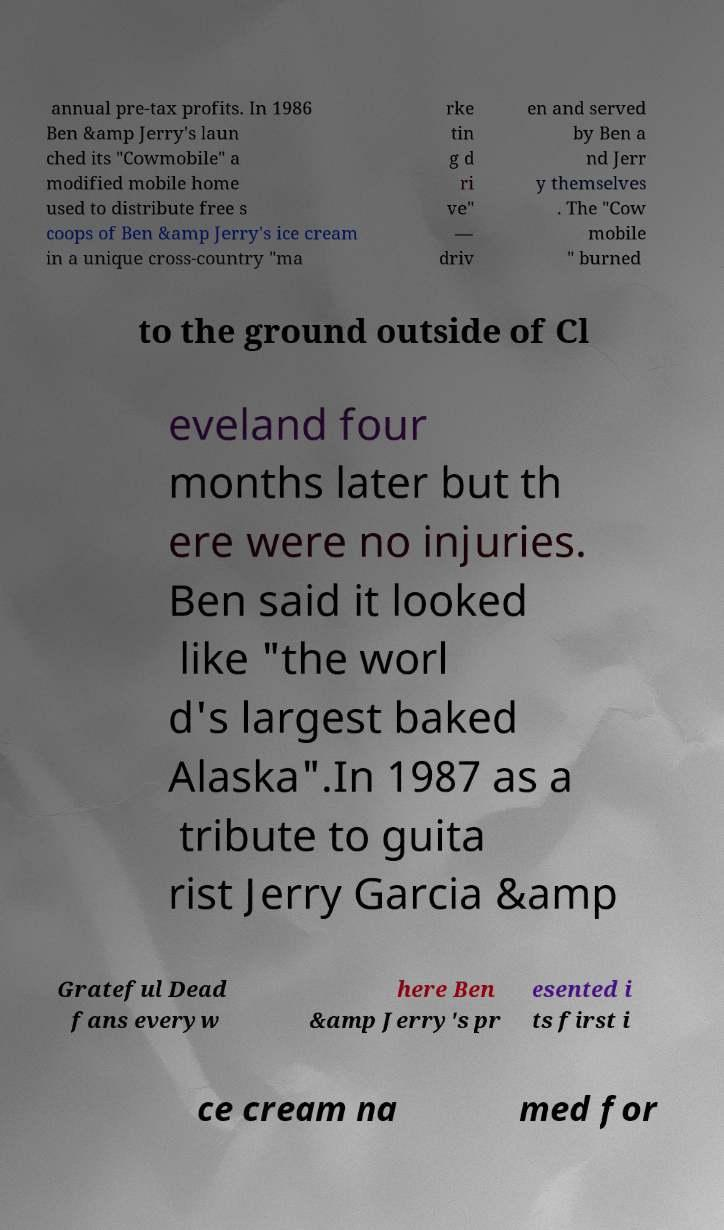I need the written content from this picture converted into text. Can you do that? annual pre-tax profits. In 1986 Ben &amp Jerry's laun ched its "Cowmobile" a modified mobile home used to distribute free s coops of Ben &amp Jerry's ice cream in a unique cross-country "ma rke tin g d ri ve" — driv en and served by Ben a nd Jerr y themselves . The "Cow mobile " burned to the ground outside of Cl eveland four months later but th ere were no injuries. Ben said it looked like "the worl d's largest baked Alaska".In 1987 as a tribute to guita rist Jerry Garcia &amp Grateful Dead fans everyw here Ben &amp Jerry's pr esented i ts first i ce cream na med for 